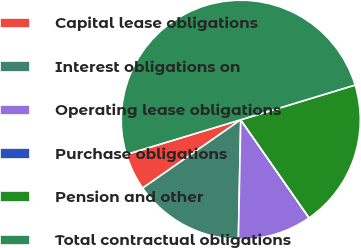Convert chart to OTSL. <chart><loc_0><loc_0><loc_500><loc_500><pie_chart><fcel>Capital lease obligations<fcel>Interest obligations on<fcel>Operating lease obligations<fcel>Purchase obligations<fcel>Pension and other<fcel>Total contractual obligations<nl><fcel>5.0%<fcel>15.0%<fcel>10.0%<fcel>0.01%<fcel>20.0%<fcel>49.99%<nl></chart> 